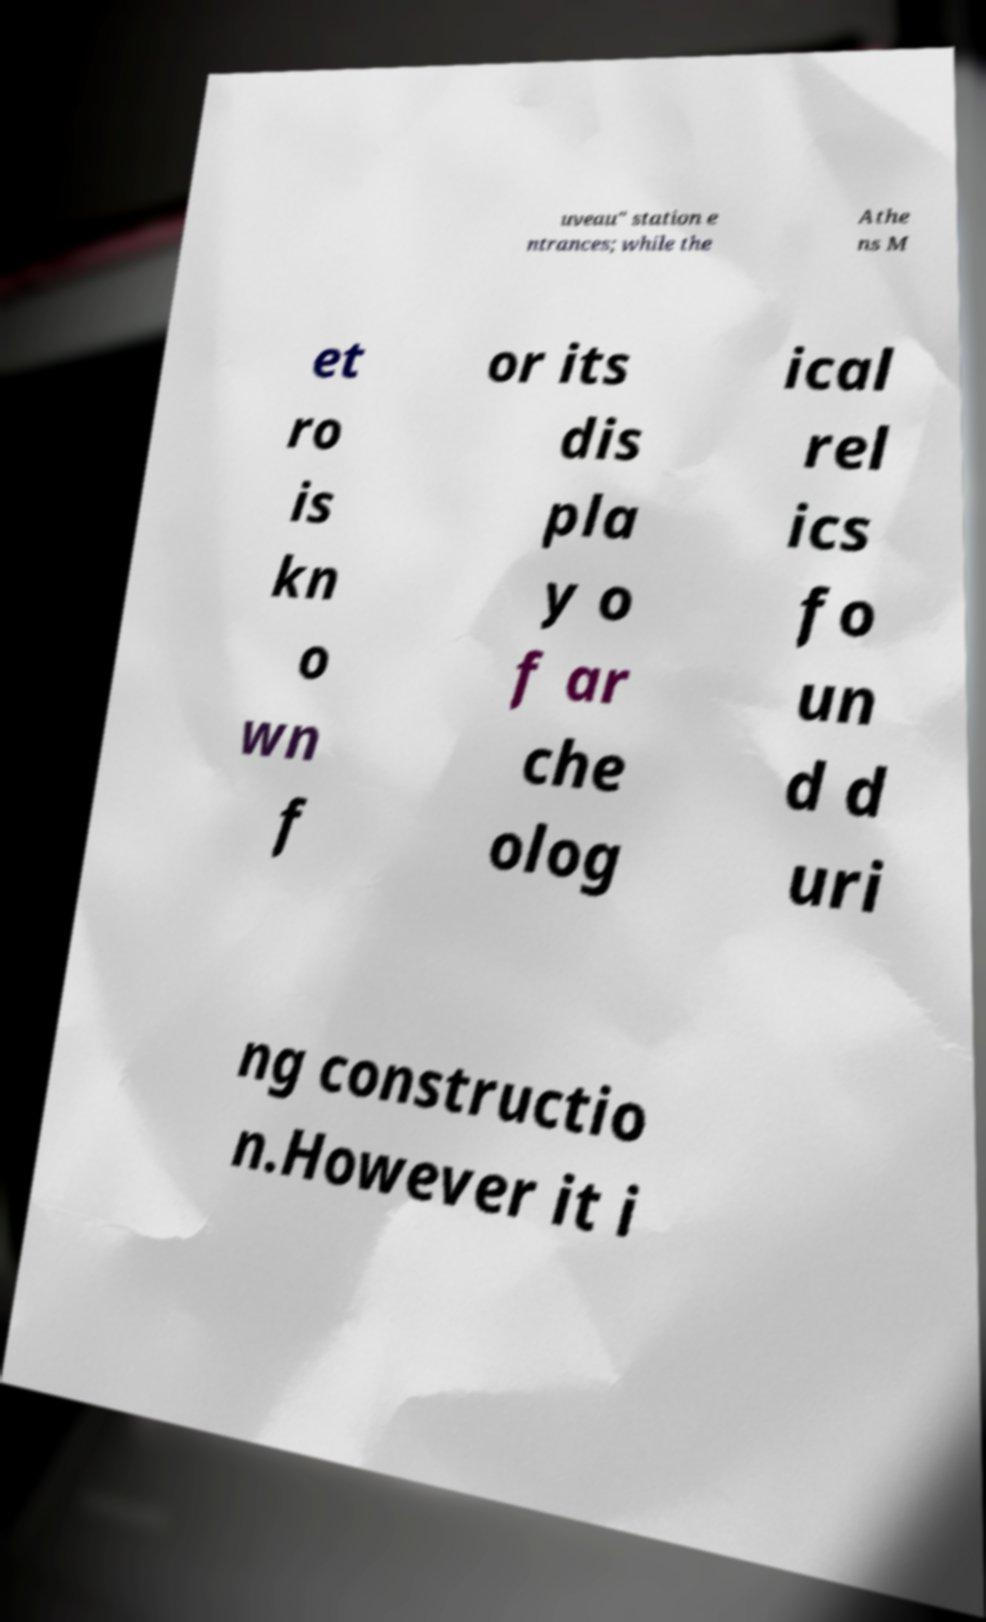What messages or text are displayed in this image? I need them in a readable, typed format. uveau" station e ntrances; while the Athe ns M et ro is kn o wn f or its dis pla y o f ar che olog ical rel ics fo un d d uri ng constructio n.However it i 